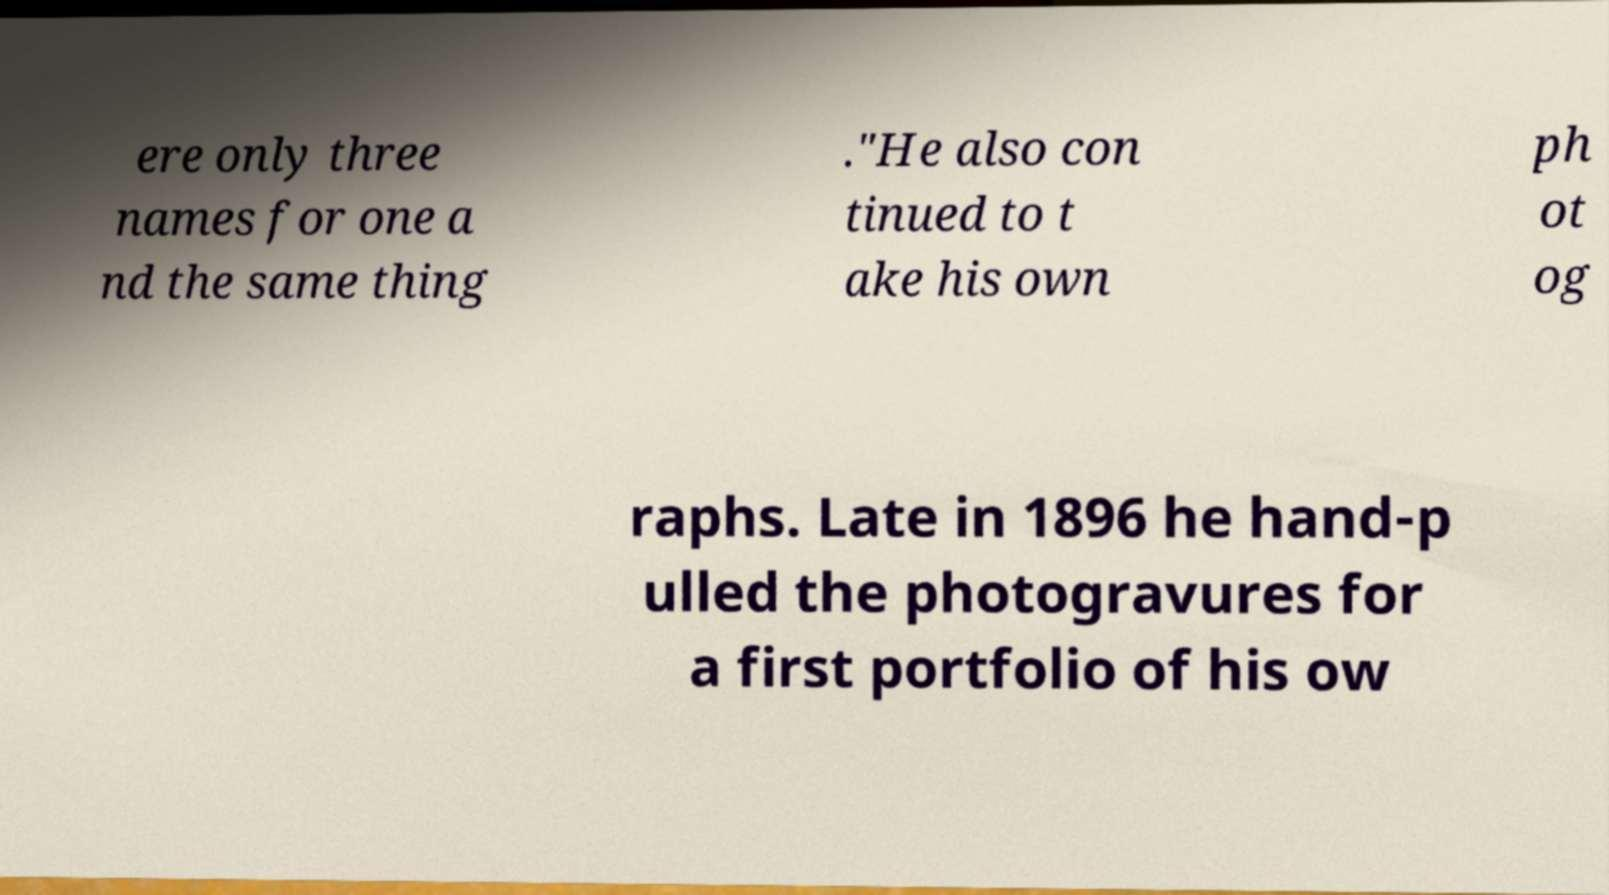For documentation purposes, I need the text within this image transcribed. Could you provide that? ere only three names for one a nd the same thing ."He also con tinued to t ake his own ph ot og raphs. Late in 1896 he hand-p ulled the photogravures for a first portfolio of his ow 